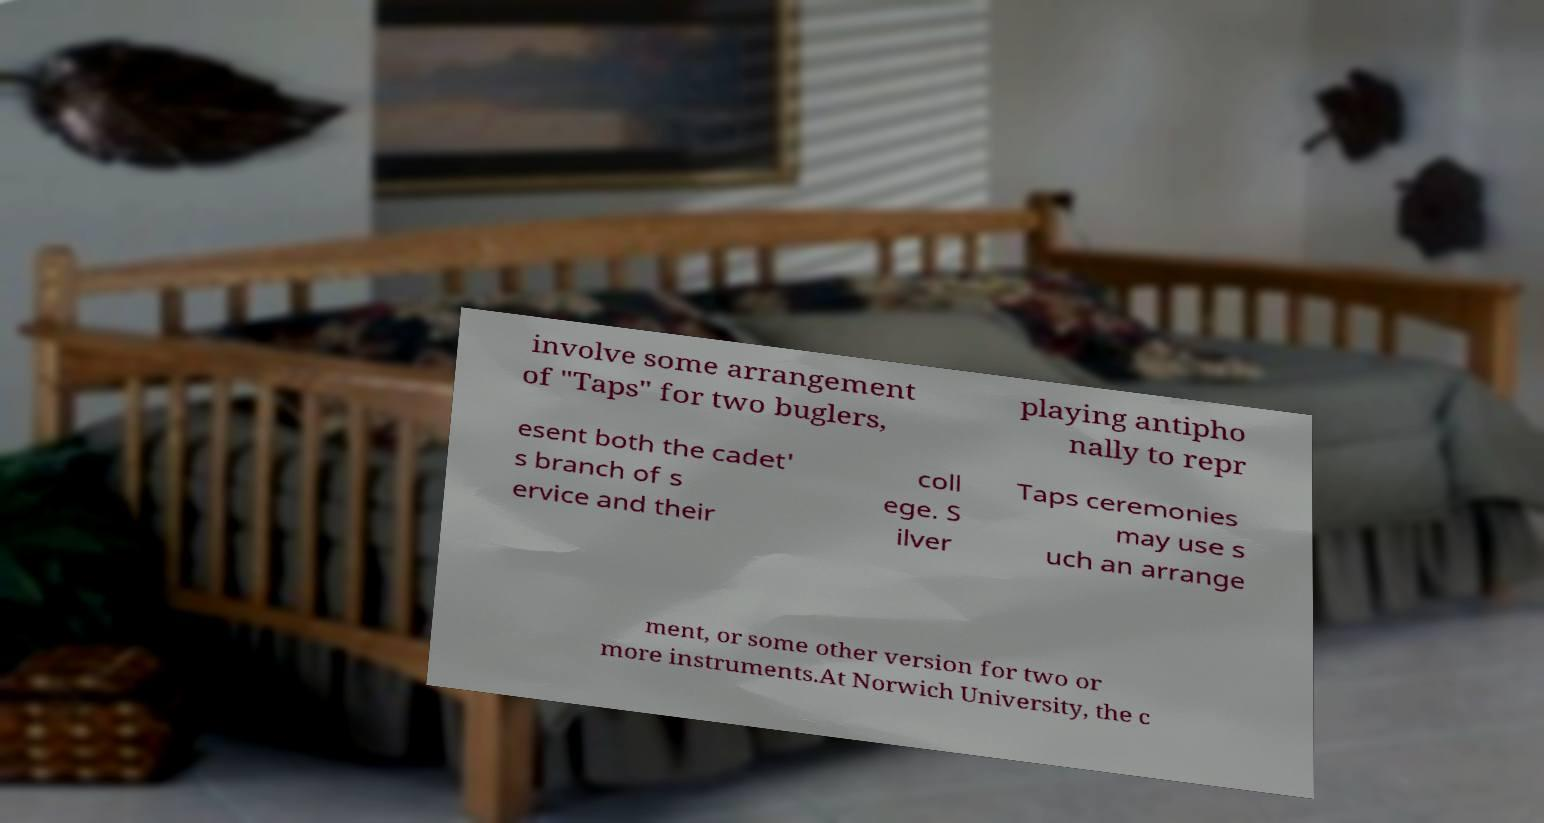Can you read and provide the text displayed in the image?This photo seems to have some interesting text. Can you extract and type it out for me? involve some arrangement of "Taps" for two buglers, playing antipho nally to repr esent both the cadet' s branch of s ervice and their coll ege. S ilver Taps ceremonies may use s uch an arrange ment, or some other version for two or more instruments.At Norwich University, the c 